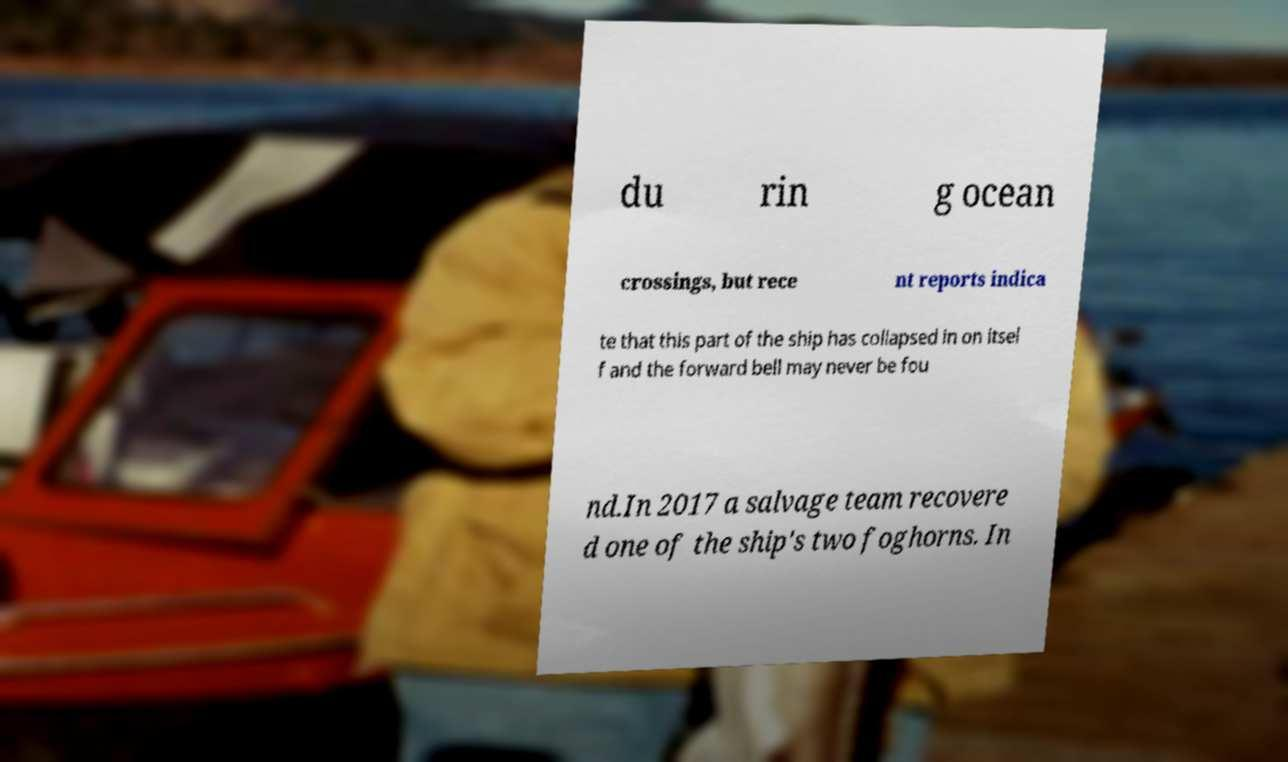Could you assist in decoding the text presented in this image and type it out clearly? du rin g ocean crossings, but rece nt reports indica te that this part of the ship has collapsed in on itsel f and the forward bell may never be fou nd.In 2017 a salvage team recovere d one of the ship's two foghorns. In 